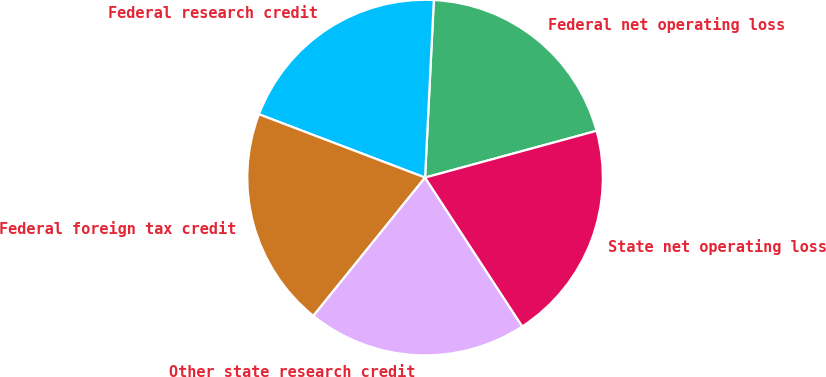Convert chart. <chart><loc_0><loc_0><loc_500><loc_500><pie_chart><fcel>Federal net operating loss<fcel>Federal research credit<fcel>Federal foreign tax credit<fcel>Other state research credit<fcel>State net operating loss<nl><fcel>19.98%<fcel>19.99%<fcel>19.98%<fcel>20.02%<fcel>20.03%<nl></chart> 